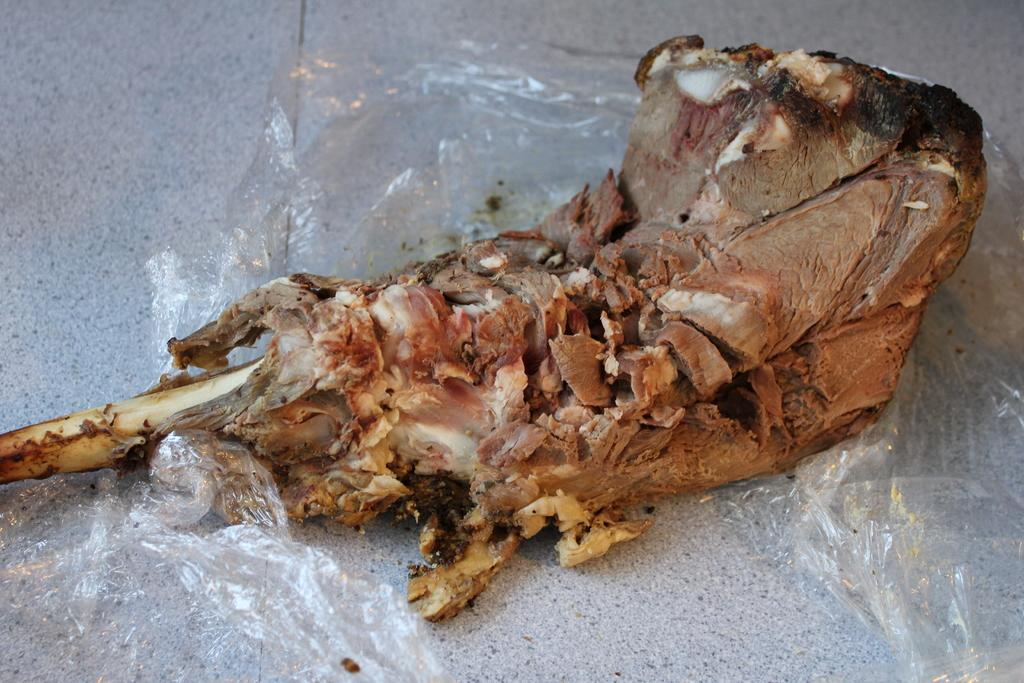What is present in the image related to food? There is food in the image. What is covering the food in the image? There is a plastic cover in the image. Where are the food and plastic cover located? The food and plastic cover are on a platform in the image. What type of vest is the boy wearing in the image? There is no boy or vest present in the image; it only features food and a plastic cover on a platform. 